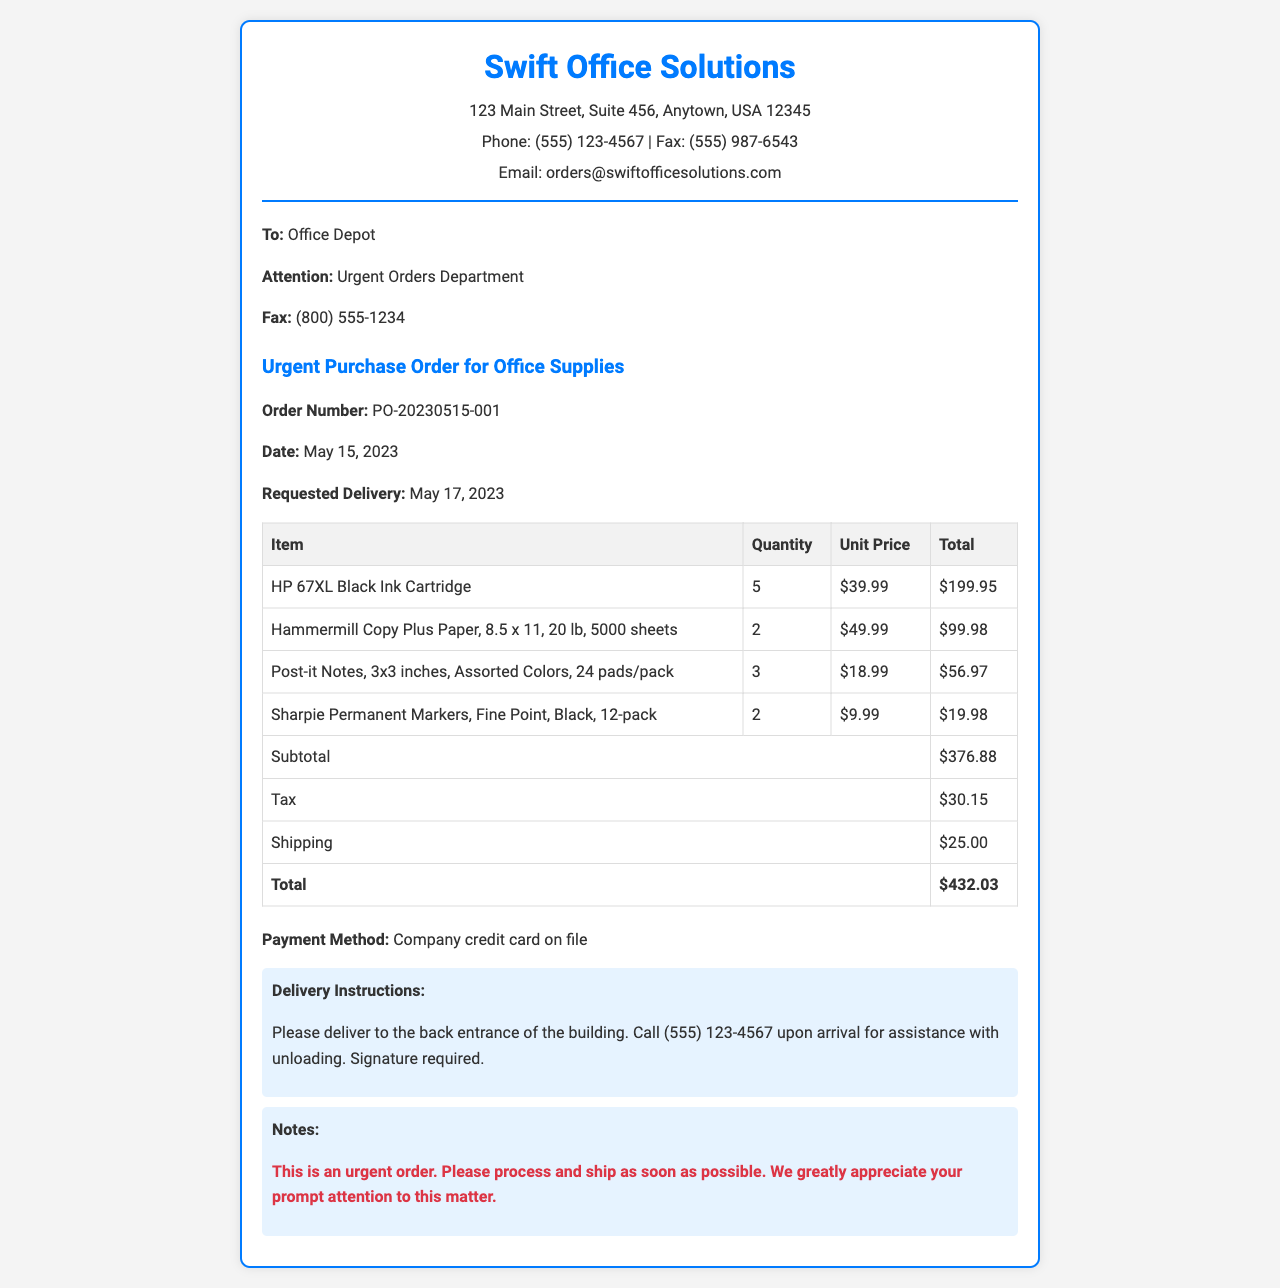What is the order number? The order number is a unique identifier for this purchase order, listed in the document.
Answer: PO-20230515-001 What is the date of the order? The date of the order is specified in the document as the day it was created.
Answer: May 15, 2023 Who is the recipient of the fax? The recipient's details are listed at the beginning of the document, providing the name and department.
Answer: Office Depot What is the total amount due for this order? The total amount is calculated at the end of the table and includes all charges.
Answer: $432.03 How many units of Post-it Notes were ordered? The quantity of Post-it Notes is indicated in the itemized list.
Answer: 3 What is the requested delivery date? The requested delivery date is specified in the document for when the order should arrive.
Answer: May 17, 2023 What payment method is used for this order? The payment method is noted in the document to explain how the order will be paid.
Answer: Company credit card on file What special instructions are given for delivery? Delivery instructions provide specifics on how and where to deliver the items.
Answer: Please deliver to the back entrance of the building. Call (555) 123-4567 upon arrival for assistance with unloading. Signature required Is this order marked as urgent? The document includes a note indicating the urgency of the order near the end.
Answer: Yes 